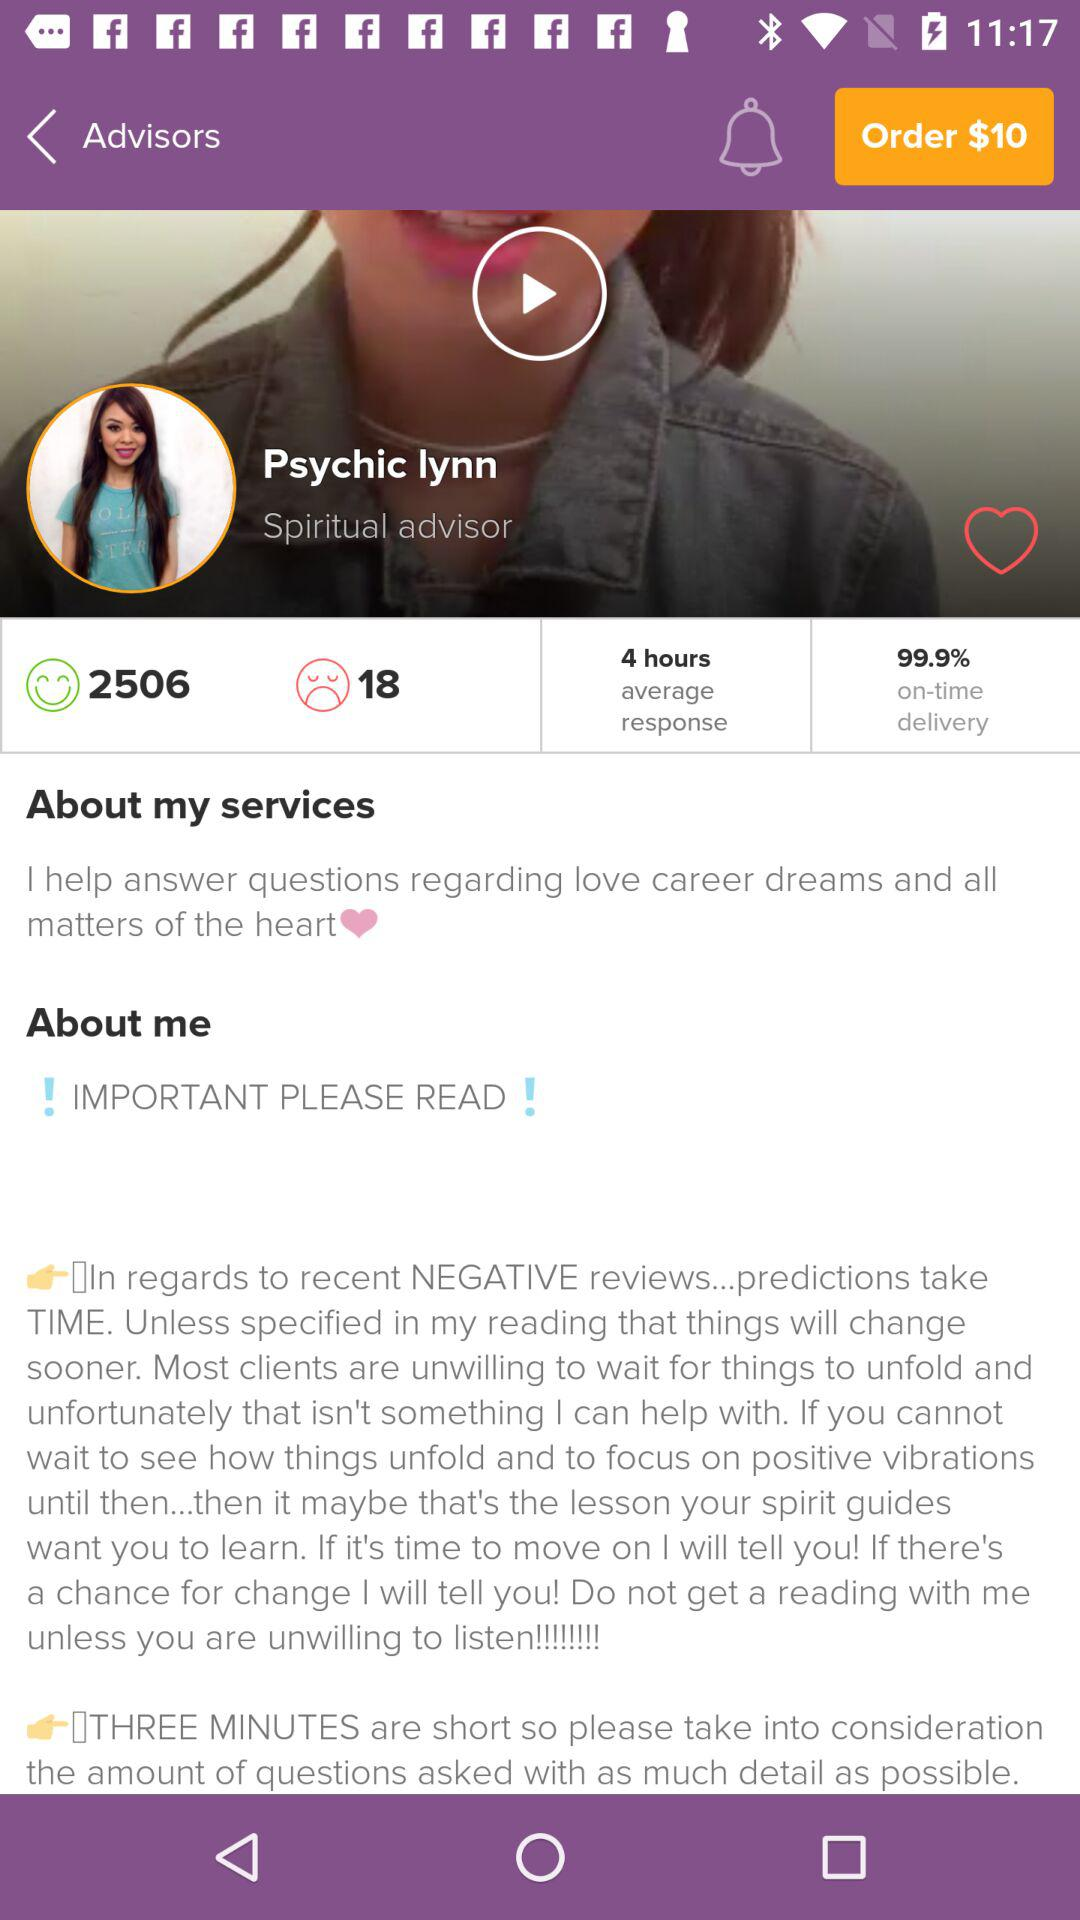What is the average response time? The average response time is 4 hours. 